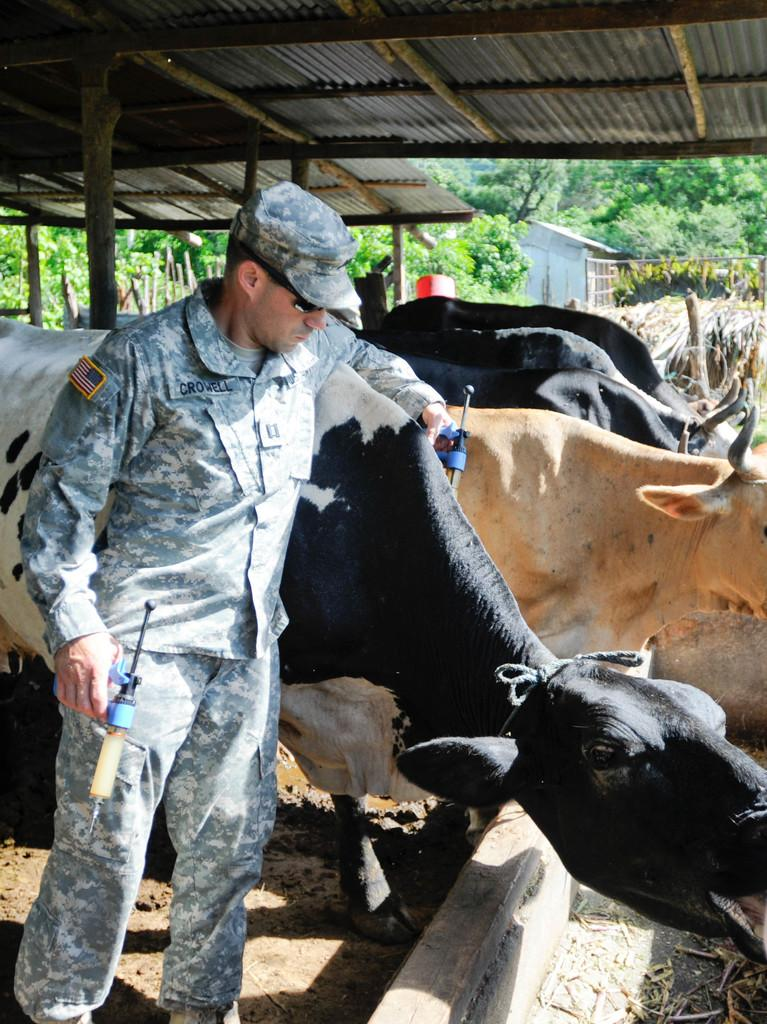Who is present in the image? There is a man in the image. What is the man holding in his hands? The man is holding an object in his hands. What can be seen on the right side of the man? There are cows on the right side of the man. Where are the cows located? The cows are in a shed. What is visible behind the cows? There are trees behind the cows. What scent can be detected from the giraffe in the image? There is no giraffe present in the image, so it is not possible to detect any scent from a giraffe. 